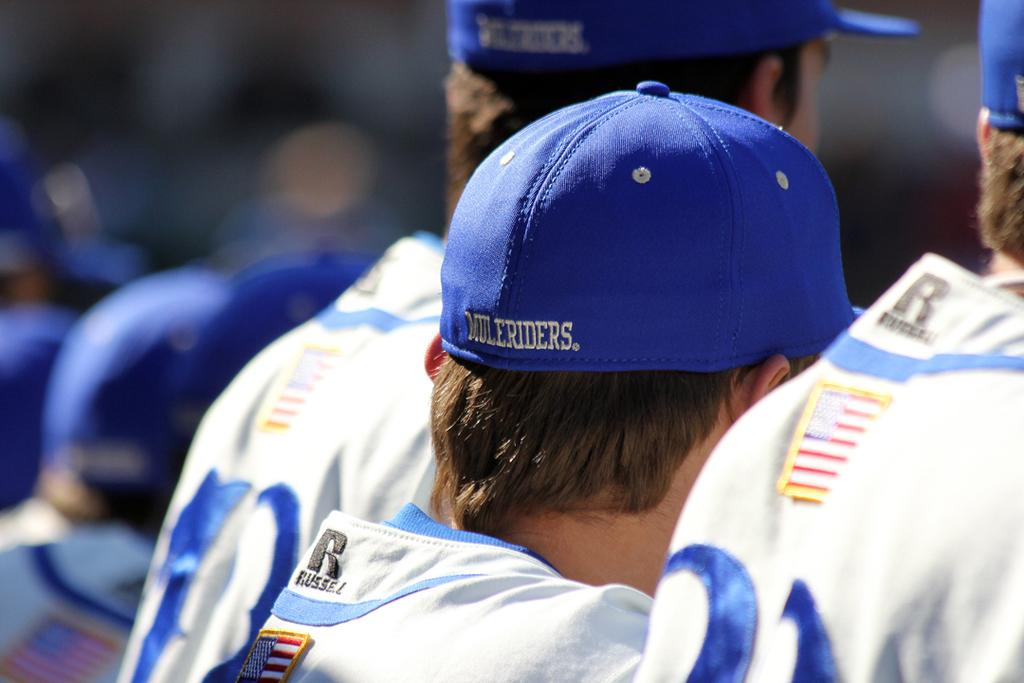<image>
Relay a brief, clear account of the picture shown. A man with a blue Muleriders baseball cap on . 